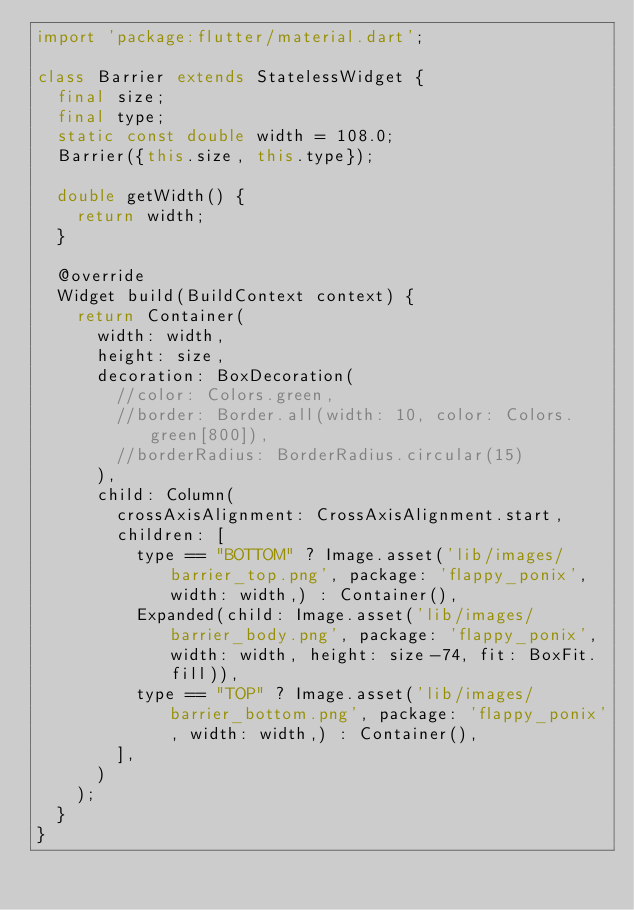Convert code to text. <code><loc_0><loc_0><loc_500><loc_500><_Dart_>import 'package:flutter/material.dart';

class Barrier extends StatelessWidget {
  final size;
  final type;
  static const double width = 108.0;
  Barrier({this.size, this.type});

  double getWidth() {
    return width;
  }

  @override
  Widget build(BuildContext context) {
    return Container(
      width: width,
      height: size,
      decoration: BoxDecoration(
        //color: Colors.green,
        //border: Border.all(width: 10, color: Colors.green[800]),
        //borderRadius: BorderRadius.circular(15)
      ),
      child: Column(
        crossAxisAlignment: CrossAxisAlignment.start,
        children: [
          type == "BOTTOM" ? Image.asset('lib/images/barrier_top.png', package: 'flappy_ponix', width: width,) : Container(),
          Expanded(child: Image.asset('lib/images/barrier_body.png', package: 'flappy_ponix', width: width, height: size-74, fit: BoxFit.fill)),
          type == "TOP" ? Image.asset('lib/images/barrier_bottom.png', package: 'flappy_ponix', width: width,) : Container(),
        ],
      )
    );
  }
}
</code> 